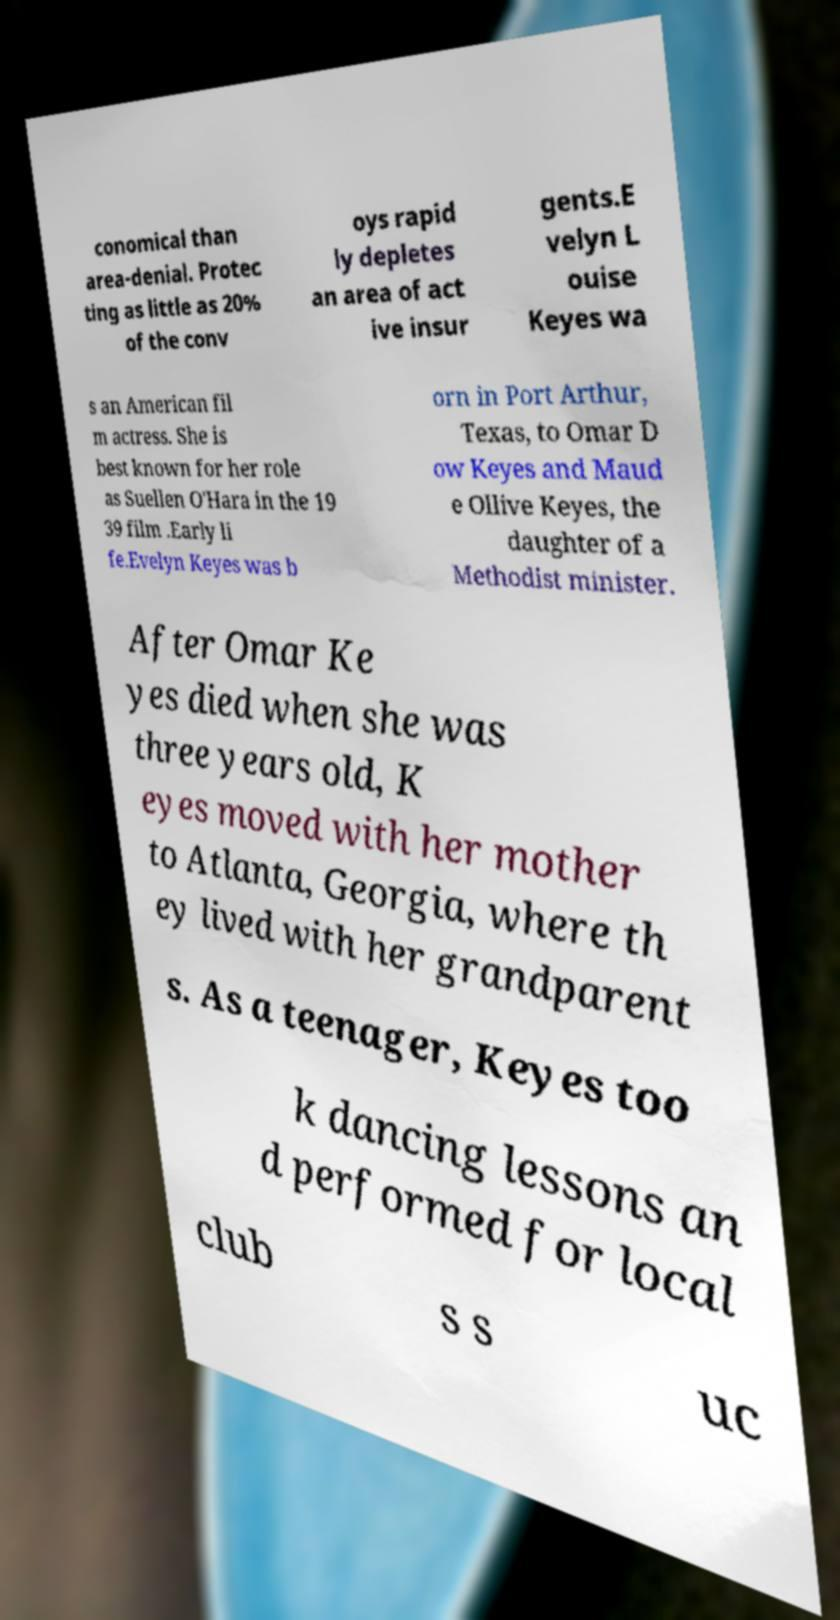Please read and relay the text visible in this image. What does it say? conomical than area-denial. Protec ting as little as 20% of the conv oys rapid ly depletes an area of act ive insur gents.E velyn L ouise Keyes wa s an American fil m actress. She is best known for her role as Suellen O'Hara in the 19 39 film .Early li fe.Evelyn Keyes was b orn in Port Arthur, Texas, to Omar D ow Keyes and Maud e Ollive Keyes, the daughter of a Methodist minister. After Omar Ke yes died when she was three years old, K eyes moved with her mother to Atlanta, Georgia, where th ey lived with her grandparent s. As a teenager, Keyes too k dancing lessons an d performed for local club s s uc 